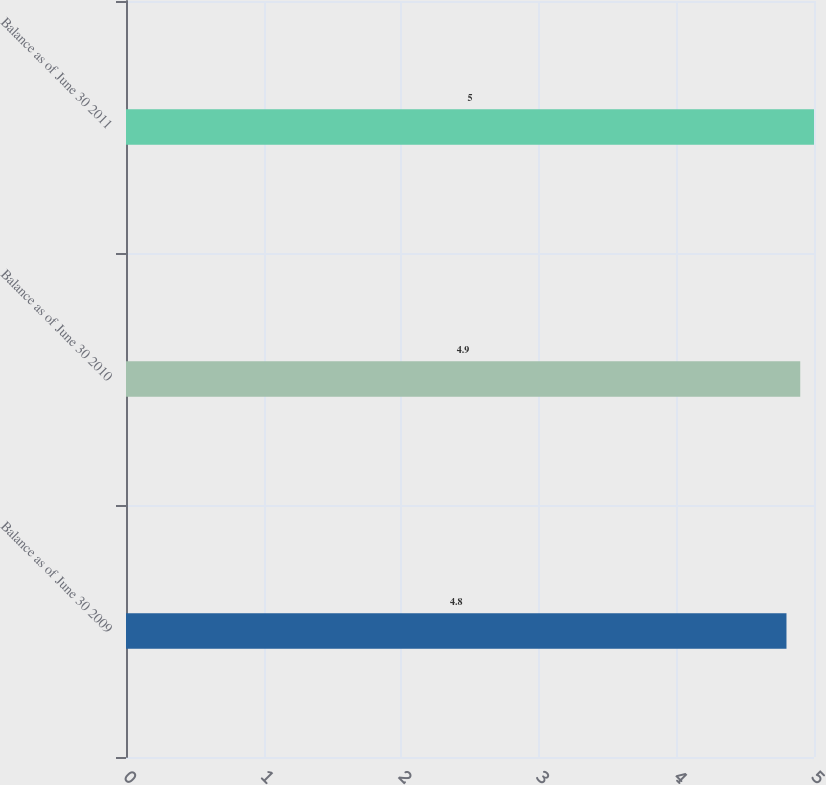Convert chart to OTSL. <chart><loc_0><loc_0><loc_500><loc_500><bar_chart><fcel>Balance as of June 30 2009<fcel>Balance as of June 30 2010<fcel>Balance as of June 30 2011<nl><fcel>4.8<fcel>4.9<fcel>5<nl></chart> 